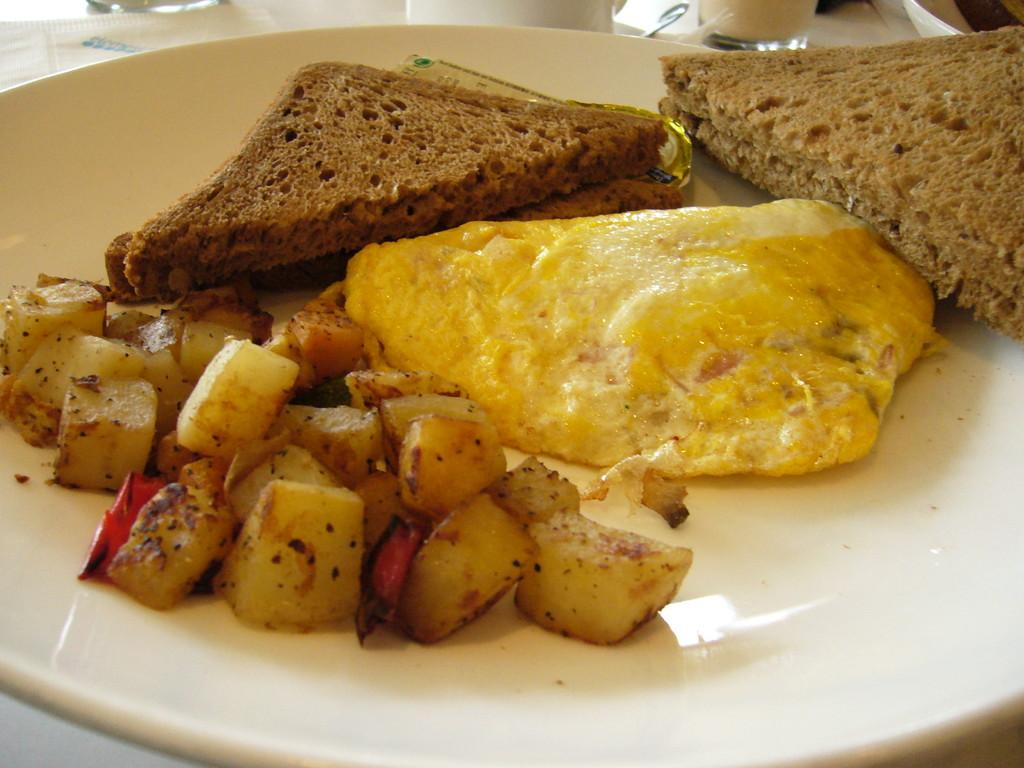What type of food can be seen in the image? There is bread in the image. What is the bread placed on in the image? There is food on a plate in the image. Where is the plate with food located? The plate is placed on a table. How does the bread compare to a fire hydrant in the image? There is no fire hydrant present in the image, so it cannot be compared to the bread. 